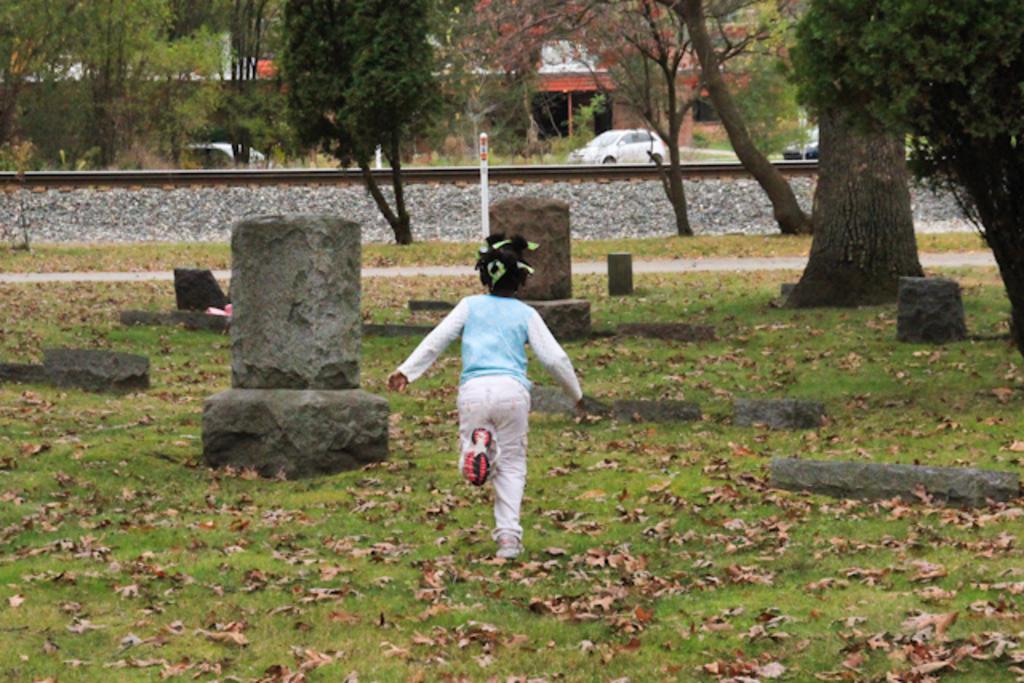Could you give a brief overview of what you see in this image? In this image there is a kid standing on the grass, and in the background there are rocks, vehicles, railway track, building, trees. 